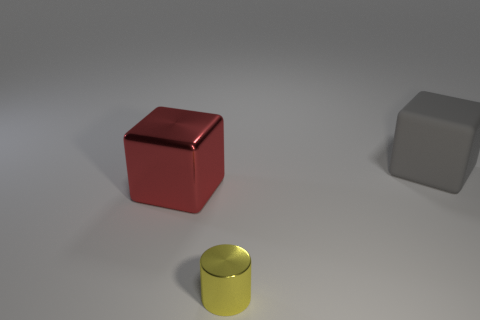Add 2 big things. How many objects exist? 5 Subtract all cylinders. How many objects are left? 2 Add 2 red blocks. How many red blocks exist? 3 Subtract 0 red cylinders. How many objects are left? 3 Subtract all red shiny objects. Subtract all big metal cubes. How many objects are left? 1 Add 3 large gray matte things. How many large gray matte things are left? 4 